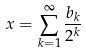Convert formula to latex. <formula><loc_0><loc_0><loc_500><loc_500>x = \sum _ { k = 1 } ^ { \infty } \frac { b _ { k } } { 2 ^ { k } }</formula> 